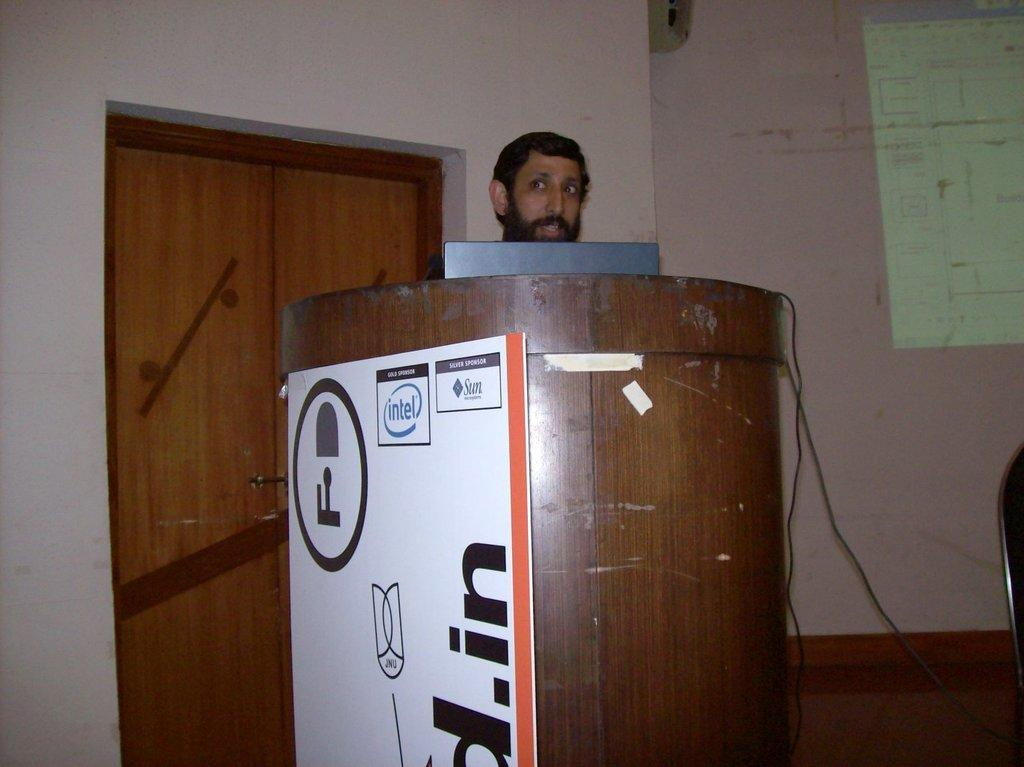<image>
Offer a succinct explanation of the picture presented. A man stands behind a podium with an intel logo on the side 